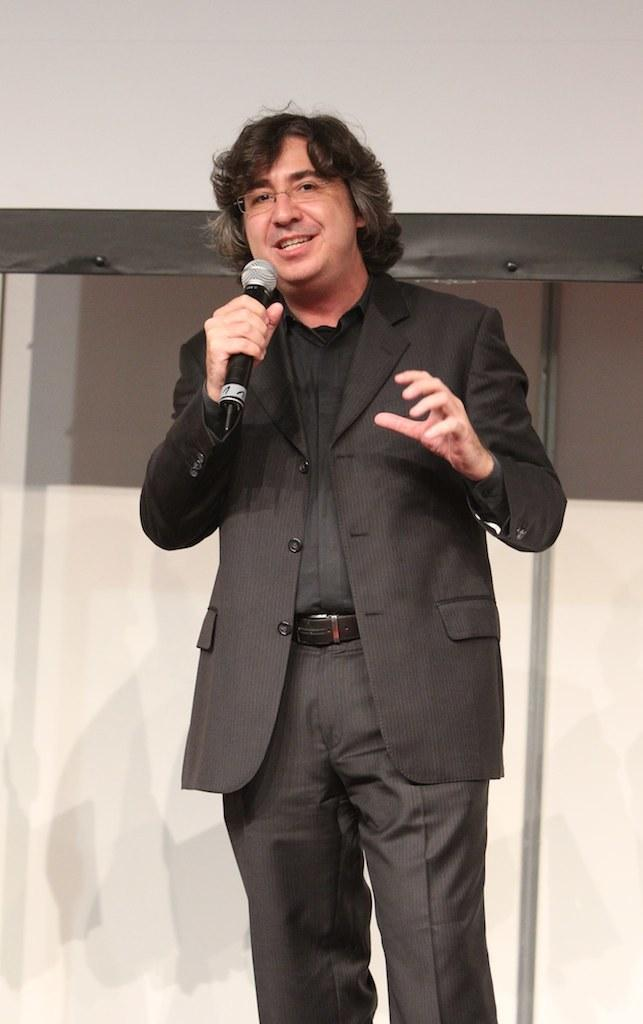Who is the main subject in the image? There is a man in the center of the image. What is the man doing in the image? The man is standing and appears to be talking. What object is the man holding in the image? The man is holding a microphone. What can be seen in the background of the image? There is a wall in the background of the image. How many pizzas are being served on the floor in the image? There are no pizzas or floors visible in the image; it features a man holding a microphone and standing in front of a wall. 